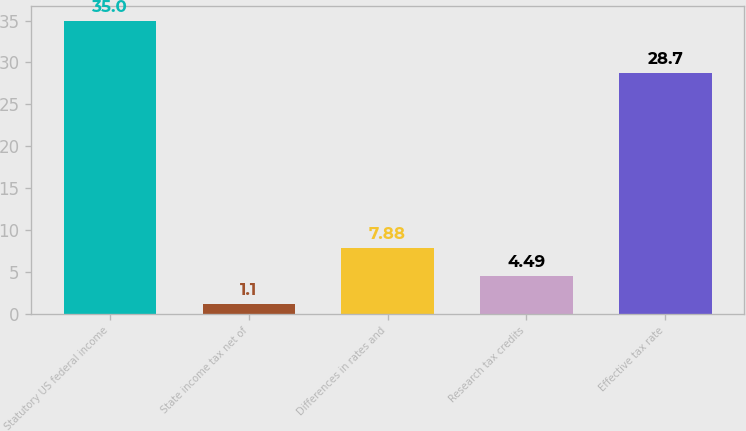Convert chart to OTSL. <chart><loc_0><loc_0><loc_500><loc_500><bar_chart><fcel>Statutory US federal income<fcel>State income tax net of<fcel>Differences in rates and<fcel>Research tax credits<fcel>Effective tax rate<nl><fcel>35<fcel>1.1<fcel>7.88<fcel>4.49<fcel>28.7<nl></chart> 